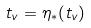Convert formula to latex. <formula><loc_0><loc_0><loc_500><loc_500>t _ { v } = \eta _ { * } ( t _ { v } )</formula> 